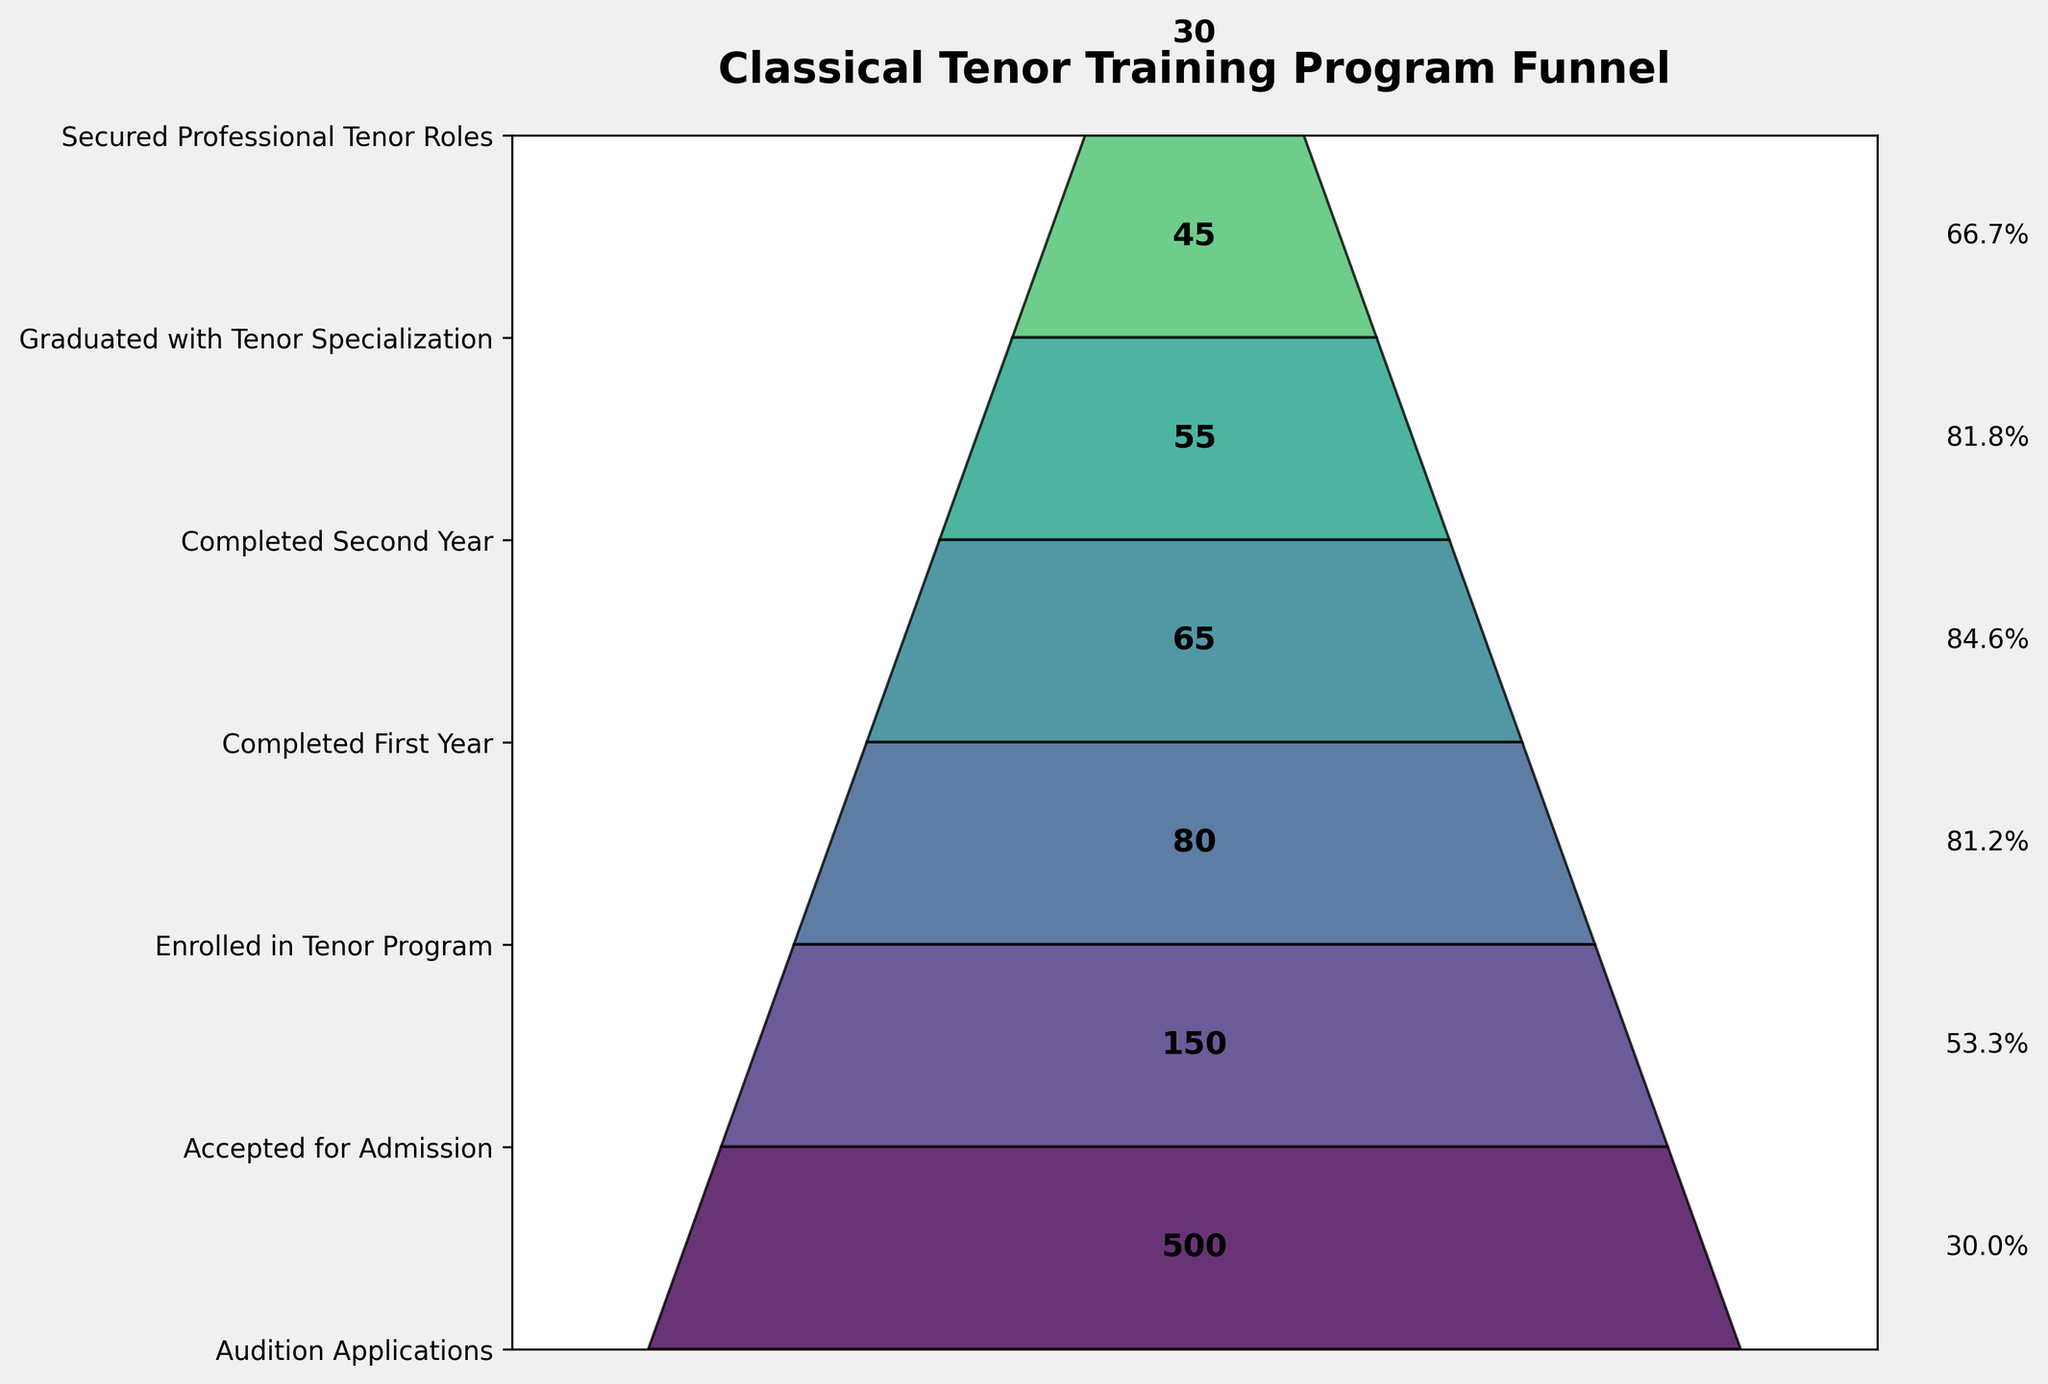How many students applied for the audition? Look at the first stage in the funnel chart to see the number of students who applied for the audition.
Answer: 500 What percentage of students who auditioned were accepted for admission? Calculate the percentage by dividing the number of students accepted for admission by the number of audition applications and then multiplying by 100. \( \frac{150}{500} \times 100 = 30\% \).
Answer: 30% How many students did not complete the first year after enrolling in the tenor program? Find the difference between the number of students who enrolled in the tenor program and those who completed the first year: \( 80 - 65 = 15 \).
Answer: 15 In which stage did the largest decrease in student numbers occur? Identify the stage with the highest absolute difference between consecutive values. The biggest drop is from "Audition Applications" (500) to "Accepted for Admission" (150), which is 350 students.
Answer: Audition Applications to Accepted for Admission What is the ratio of students who graduated with a tenor specialization to those who secured professional tenor roles? Divide the number of students who secured professional roles by the number who graduated: \( \frac{30}{45} = \frac{2}{3} \).
Answer: 2:3 How many stages are there in the funnel chart? Count the total number of stages listed on the y-axis of the funnel chart.
Answer: 7 What is the percentage of students who secured professional roles among those who completed the second year? Calculate the percentage by dividing the number of students who secured professional roles by the number who completed the second year, then multiply by 100. \( \frac{30}{55} \times 100 \approx 54.5\% \).
Answer: 54.5% What is the title of the funnel chart? Read the title located at the top of the funnel chart.
Answer: Classical Tenor Training Program Funnel 